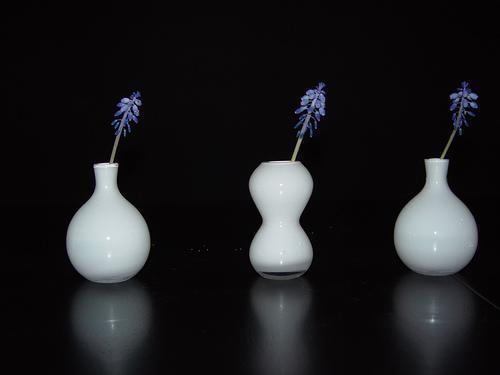How many vases are visible?
Give a very brief answer. 3. How many green bottles are on the table?
Give a very brief answer. 0. 